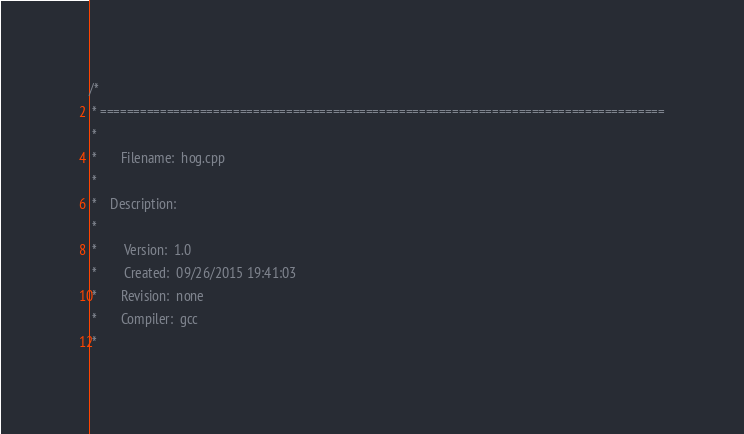Convert code to text. <code><loc_0><loc_0><loc_500><loc_500><_C++_>/*
 * =====================================================================================
 *
 *       Filename:  hog.cpp
 *
 *    Description:
 *
 *        Version:  1.0
 *        Created:  09/26/2015 19:41:03
 *       Revision:  none
 *       Compiler:  gcc
 *</code> 